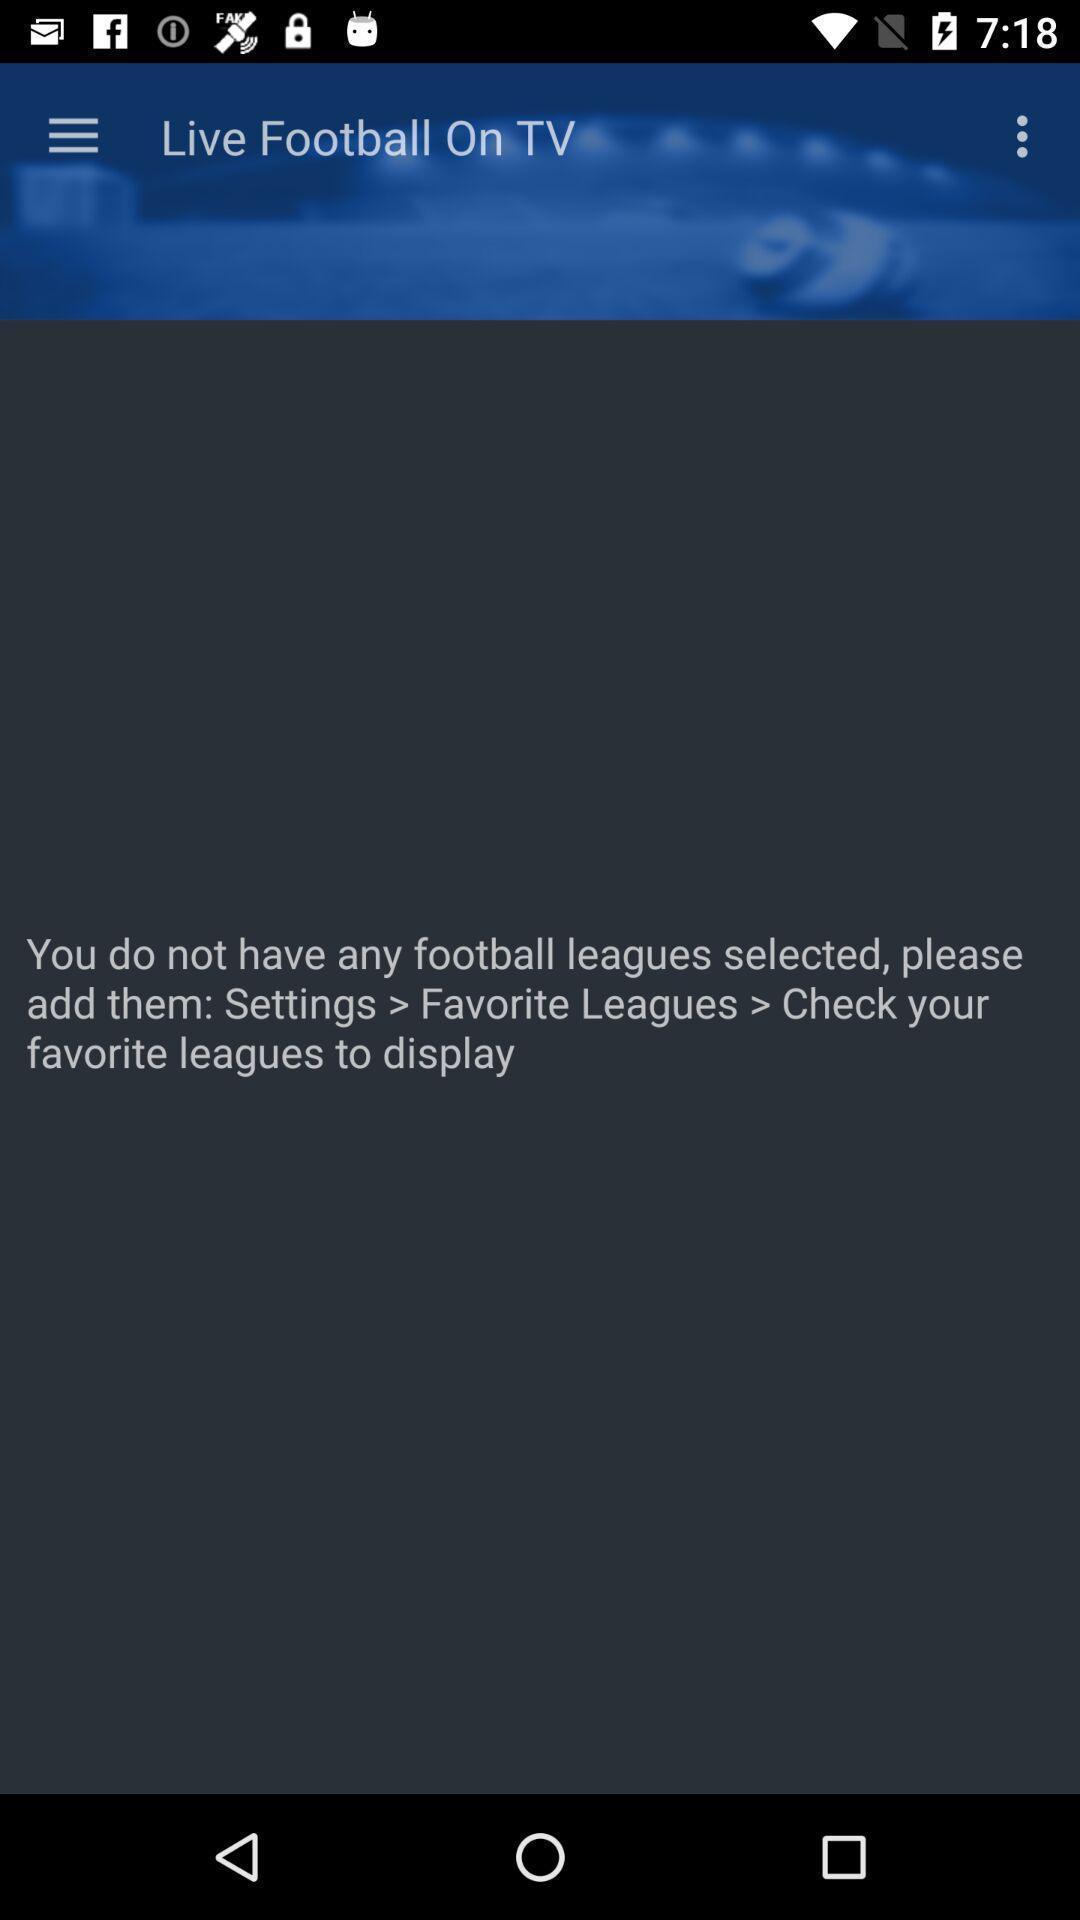Describe this image in words. Screen displaying screen page of football app. 